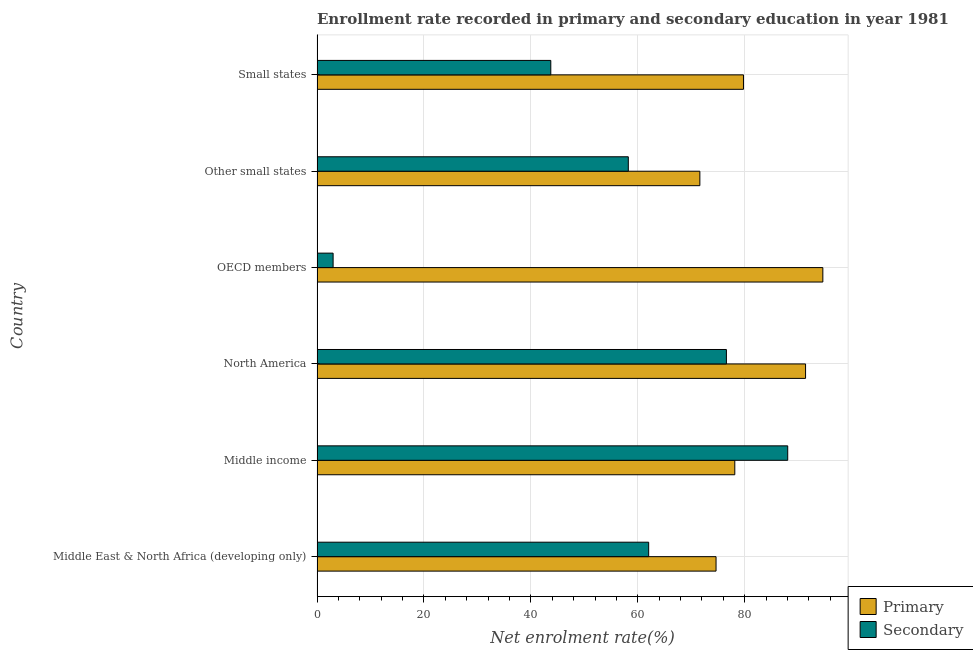How many different coloured bars are there?
Ensure brevity in your answer.  2. How many groups of bars are there?
Your answer should be compact. 6. Are the number of bars per tick equal to the number of legend labels?
Offer a very short reply. Yes. How many bars are there on the 6th tick from the top?
Give a very brief answer. 2. What is the label of the 1st group of bars from the top?
Keep it short and to the point. Small states. What is the enrollment rate in primary education in North America?
Your response must be concise. 91.38. Across all countries, what is the maximum enrollment rate in secondary education?
Your answer should be very brief. 88.04. Across all countries, what is the minimum enrollment rate in primary education?
Your answer should be compact. 71.61. In which country was the enrollment rate in secondary education minimum?
Keep it short and to the point. OECD members. What is the total enrollment rate in secondary education in the graph?
Your answer should be very brief. 331.59. What is the difference between the enrollment rate in secondary education in OECD members and that in Other small states?
Provide a succinct answer. -55.22. What is the difference between the enrollment rate in primary education in OECD members and the enrollment rate in secondary education in Middle East & North Africa (developing only)?
Provide a succinct answer. 32.58. What is the average enrollment rate in secondary education per country?
Your answer should be compact. 55.27. What is the difference between the enrollment rate in secondary education and enrollment rate in primary education in OECD members?
Ensure brevity in your answer.  -91.61. What is the ratio of the enrollment rate in secondary education in OECD members to that in Small states?
Keep it short and to the point. 0.07. Is the enrollment rate in primary education in Middle income less than that in North America?
Keep it short and to the point. Yes. Is the difference between the enrollment rate in secondary education in Other small states and Small states greater than the difference between the enrollment rate in primary education in Other small states and Small states?
Provide a short and direct response. Yes. What is the difference between the highest and the second highest enrollment rate in secondary education?
Offer a very short reply. 11.47. What is the difference between the highest and the lowest enrollment rate in secondary education?
Offer a terse response. 85.04. What does the 2nd bar from the top in Small states represents?
Your answer should be very brief. Primary. What does the 2nd bar from the bottom in Middle income represents?
Make the answer very short. Secondary. How many bars are there?
Provide a short and direct response. 12. How many countries are there in the graph?
Offer a terse response. 6. Are the values on the major ticks of X-axis written in scientific E-notation?
Your answer should be compact. No. Does the graph contain any zero values?
Offer a terse response. No. Does the graph contain grids?
Your response must be concise. Yes. How many legend labels are there?
Provide a succinct answer. 2. What is the title of the graph?
Your answer should be very brief. Enrollment rate recorded in primary and secondary education in year 1981. Does "Urban" appear as one of the legend labels in the graph?
Offer a very short reply. No. What is the label or title of the X-axis?
Your answer should be very brief. Net enrolment rate(%). What is the label or title of the Y-axis?
Offer a very short reply. Country. What is the Net enrolment rate(%) of Primary in Middle East & North Africa (developing only)?
Keep it short and to the point. 74.63. What is the Net enrolment rate(%) in Secondary in Middle East & North Africa (developing only)?
Offer a very short reply. 62.03. What is the Net enrolment rate(%) in Primary in Middle income?
Provide a short and direct response. 78.14. What is the Net enrolment rate(%) of Secondary in Middle income?
Offer a very short reply. 88.04. What is the Net enrolment rate(%) of Primary in North America?
Ensure brevity in your answer.  91.38. What is the Net enrolment rate(%) in Secondary in North America?
Your response must be concise. 76.57. What is the Net enrolment rate(%) of Primary in OECD members?
Offer a very short reply. 94.61. What is the Net enrolment rate(%) in Secondary in OECD members?
Your answer should be very brief. 3. What is the Net enrolment rate(%) of Primary in Other small states?
Make the answer very short. 71.61. What is the Net enrolment rate(%) in Secondary in Other small states?
Ensure brevity in your answer.  58.22. What is the Net enrolment rate(%) in Primary in Small states?
Ensure brevity in your answer.  79.76. What is the Net enrolment rate(%) in Secondary in Small states?
Make the answer very short. 43.72. Across all countries, what is the maximum Net enrolment rate(%) in Primary?
Your answer should be very brief. 94.61. Across all countries, what is the maximum Net enrolment rate(%) in Secondary?
Provide a succinct answer. 88.04. Across all countries, what is the minimum Net enrolment rate(%) of Primary?
Keep it short and to the point. 71.61. Across all countries, what is the minimum Net enrolment rate(%) in Secondary?
Give a very brief answer. 3. What is the total Net enrolment rate(%) of Primary in the graph?
Your answer should be compact. 490.13. What is the total Net enrolment rate(%) of Secondary in the graph?
Offer a terse response. 331.59. What is the difference between the Net enrolment rate(%) in Primary in Middle East & North Africa (developing only) and that in Middle income?
Your response must be concise. -3.51. What is the difference between the Net enrolment rate(%) of Secondary in Middle East & North Africa (developing only) and that in Middle income?
Offer a very short reply. -26.01. What is the difference between the Net enrolment rate(%) in Primary in Middle East & North Africa (developing only) and that in North America?
Your answer should be very brief. -16.75. What is the difference between the Net enrolment rate(%) in Secondary in Middle East & North Africa (developing only) and that in North America?
Ensure brevity in your answer.  -14.54. What is the difference between the Net enrolment rate(%) of Primary in Middle East & North Africa (developing only) and that in OECD members?
Offer a very short reply. -19.98. What is the difference between the Net enrolment rate(%) in Secondary in Middle East & North Africa (developing only) and that in OECD members?
Your response must be concise. 59.03. What is the difference between the Net enrolment rate(%) in Primary in Middle East & North Africa (developing only) and that in Other small states?
Ensure brevity in your answer.  3.03. What is the difference between the Net enrolment rate(%) of Secondary in Middle East & North Africa (developing only) and that in Other small states?
Your answer should be compact. 3.81. What is the difference between the Net enrolment rate(%) of Primary in Middle East & North Africa (developing only) and that in Small states?
Make the answer very short. -5.13. What is the difference between the Net enrolment rate(%) of Secondary in Middle East & North Africa (developing only) and that in Small states?
Your answer should be very brief. 18.31. What is the difference between the Net enrolment rate(%) in Primary in Middle income and that in North America?
Offer a very short reply. -13.24. What is the difference between the Net enrolment rate(%) of Secondary in Middle income and that in North America?
Your answer should be compact. 11.47. What is the difference between the Net enrolment rate(%) in Primary in Middle income and that in OECD members?
Provide a short and direct response. -16.47. What is the difference between the Net enrolment rate(%) of Secondary in Middle income and that in OECD members?
Provide a short and direct response. 85.04. What is the difference between the Net enrolment rate(%) in Primary in Middle income and that in Other small states?
Your answer should be compact. 6.53. What is the difference between the Net enrolment rate(%) in Secondary in Middle income and that in Other small states?
Give a very brief answer. 29.82. What is the difference between the Net enrolment rate(%) of Primary in Middle income and that in Small states?
Provide a short and direct response. -1.62. What is the difference between the Net enrolment rate(%) in Secondary in Middle income and that in Small states?
Give a very brief answer. 44.32. What is the difference between the Net enrolment rate(%) in Primary in North America and that in OECD members?
Provide a short and direct response. -3.23. What is the difference between the Net enrolment rate(%) of Secondary in North America and that in OECD members?
Your answer should be very brief. 73.57. What is the difference between the Net enrolment rate(%) of Primary in North America and that in Other small states?
Offer a very short reply. 19.77. What is the difference between the Net enrolment rate(%) of Secondary in North America and that in Other small states?
Provide a succinct answer. 18.35. What is the difference between the Net enrolment rate(%) in Primary in North America and that in Small states?
Ensure brevity in your answer.  11.62. What is the difference between the Net enrolment rate(%) in Secondary in North America and that in Small states?
Your answer should be very brief. 32.85. What is the difference between the Net enrolment rate(%) of Primary in OECD members and that in Other small states?
Offer a very short reply. 23. What is the difference between the Net enrolment rate(%) in Secondary in OECD members and that in Other small states?
Make the answer very short. -55.22. What is the difference between the Net enrolment rate(%) of Primary in OECD members and that in Small states?
Give a very brief answer. 14.85. What is the difference between the Net enrolment rate(%) of Secondary in OECD members and that in Small states?
Make the answer very short. -40.72. What is the difference between the Net enrolment rate(%) of Primary in Other small states and that in Small states?
Provide a short and direct response. -8.16. What is the difference between the Net enrolment rate(%) of Secondary in Other small states and that in Small states?
Your response must be concise. 14.5. What is the difference between the Net enrolment rate(%) in Primary in Middle East & North Africa (developing only) and the Net enrolment rate(%) in Secondary in Middle income?
Provide a succinct answer. -13.41. What is the difference between the Net enrolment rate(%) of Primary in Middle East & North Africa (developing only) and the Net enrolment rate(%) of Secondary in North America?
Your answer should be very brief. -1.94. What is the difference between the Net enrolment rate(%) in Primary in Middle East & North Africa (developing only) and the Net enrolment rate(%) in Secondary in OECD members?
Ensure brevity in your answer.  71.63. What is the difference between the Net enrolment rate(%) of Primary in Middle East & North Africa (developing only) and the Net enrolment rate(%) of Secondary in Other small states?
Ensure brevity in your answer.  16.41. What is the difference between the Net enrolment rate(%) of Primary in Middle East & North Africa (developing only) and the Net enrolment rate(%) of Secondary in Small states?
Offer a terse response. 30.91. What is the difference between the Net enrolment rate(%) of Primary in Middle income and the Net enrolment rate(%) of Secondary in North America?
Keep it short and to the point. 1.57. What is the difference between the Net enrolment rate(%) in Primary in Middle income and the Net enrolment rate(%) in Secondary in OECD members?
Provide a succinct answer. 75.14. What is the difference between the Net enrolment rate(%) in Primary in Middle income and the Net enrolment rate(%) in Secondary in Other small states?
Your answer should be compact. 19.92. What is the difference between the Net enrolment rate(%) in Primary in Middle income and the Net enrolment rate(%) in Secondary in Small states?
Your answer should be very brief. 34.42. What is the difference between the Net enrolment rate(%) in Primary in North America and the Net enrolment rate(%) in Secondary in OECD members?
Your answer should be compact. 88.37. What is the difference between the Net enrolment rate(%) in Primary in North America and the Net enrolment rate(%) in Secondary in Other small states?
Keep it short and to the point. 33.16. What is the difference between the Net enrolment rate(%) in Primary in North America and the Net enrolment rate(%) in Secondary in Small states?
Provide a succinct answer. 47.66. What is the difference between the Net enrolment rate(%) in Primary in OECD members and the Net enrolment rate(%) in Secondary in Other small states?
Give a very brief answer. 36.39. What is the difference between the Net enrolment rate(%) of Primary in OECD members and the Net enrolment rate(%) of Secondary in Small states?
Your answer should be very brief. 50.89. What is the difference between the Net enrolment rate(%) of Primary in Other small states and the Net enrolment rate(%) of Secondary in Small states?
Provide a succinct answer. 27.89. What is the average Net enrolment rate(%) in Primary per country?
Offer a very short reply. 81.69. What is the average Net enrolment rate(%) of Secondary per country?
Provide a short and direct response. 55.27. What is the difference between the Net enrolment rate(%) of Primary and Net enrolment rate(%) of Secondary in Middle East & North Africa (developing only)?
Your response must be concise. 12.6. What is the difference between the Net enrolment rate(%) of Primary and Net enrolment rate(%) of Secondary in Middle income?
Make the answer very short. -9.9. What is the difference between the Net enrolment rate(%) of Primary and Net enrolment rate(%) of Secondary in North America?
Ensure brevity in your answer.  14.81. What is the difference between the Net enrolment rate(%) in Primary and Net enrolment rate(%) in Secondary in OECD members?
Give a very brief answer. 91.61. What is the difference between the Net enrolment rate(%) in Primary and Net enrolment rate(%) in Secondary in Other small states?
Your answer should be compact. 13.39. What is the difference between the Net enrolment rate(%) in Primary and Net enrolment rate(%) in Secondary in Small states?
Offer a terse response. 36.04. What is the ratio of the Net enrolment rate(%) in Primary in Middle East & North Africa (developing only) to that in Middle income?
Make the answer very short. 0.96. What is the ratio of the Net enrolment rate(%) of Secondary in Middle East & North Africa (developing only) to that in Middle income?
Your response must be concise. 0.7. What is the ratio of the Net enrolment rate(%) in Primary in Middle East & North Africa (developing only) to that in North America?
Your answer should be compact. 0.82. What is the ratio of the Net enrolment rate(%) in Secondary in Middle East & North Africa (developing only) to that in North America?
Make the answer very short. 0.81. What is the ratio of the Net enrolment rate(%) of Primary in Middle East & North Africa (developing only) to that in OECD members?
Give a very brief answer. 0.79. What is the ratio of the Net enrolment rate(%) in Secondary in Middle East & North Africa (developing only) to that in OECD members?
Your answer should be compact. 20.65. What is the ratio of the Net enrolment rate(%) of Primary in Middle East & North Africa (developing only) to that in Other small states?
Ensure brevity in your answer.  1.04. What is the ratio of the Net enrolment rate(%) of Secondary in Middle East & North Africa (developing only) to that in Other small states?
Your response must be concise. 1.07. What is the ratio of the Net enrolment rate(%) in Primary in Middle East & North Africa (developing only) to that in Small states?
Provide a succinct answer. 0.94. What is the ratio of the Net enrolment rate(%) of Secondary in Middle East & North Africa (developing only) to that in Small states?
Provide a short and direct response. 1.42. What is the ratio of the Net enrolment rate(%) of Primary in Middle income to that in North America?
Your answer should be compact. 0.86. What is the ratio of the Net enrolment rate(%) in Secondary in Middle income to that in North America?
Provide a succinct answer. 1.15. What is the ratio of the Net enrolment rate(%) of Primary in Middle income to that in OECD members?
Provide a short and direct response. 0.83. What is the ratio of the Net enrolment rate(%) in Secondary in Middle income to that in OECD members?
Your answer should be very brief. 29.31. What is the ratio of the Net enrolment rate(%) of Primary in Middle income to that in Other small states?
Provide a short and direct response. 1.09. What is the ratio of the Net enrolment rate(%) in Secondary in Middle income to that in Other small states?
Make the answer very short. 1.51. What is the ratio of the Net enrolment rate(%) in Primary in Middle income to that in Small states?
Your response must be concise. 0.98. What is the ratio of the Net enrolment rate(%) of Secondary in Middle income to that in Small states?
Your answer should be compact. 2.01. What is the ratio of the Net enrolment rate(%) in Primary in North America to that in OECD members?
Provide a short and direct response. 0.97. What is the ratio of the Net enrolment rate(%) in Secondary in North America to that in OECD members?
Your answer should be compact. 25.49. What is the ratio of the Net enrolment rate(%) of Primary in North America to that in Other small states?
Give a very brief answer. 1.28. What is the ratio of the Net enrolment rate(%) of Secondary in North America to that in Other small states?
Provide a short and direct response. 1.32. What is the ratio of the Net enrolment rate(%) in Primary in North America to that in Small states?
Provide a succinct answer. 1.15. What is the ratio of the Net enrolment rate(%) in Secondary in North America to that in Small states?
Offer a terse response. 1.75. What is the ratio of the Net enrolment rate(%) of Primary in OECD members to that in Other small states?
Provide a short and direct response. 1.32. What is the ratio of the Net enrolment rate(%) of Secondary in OECD members to that in Other small states?
Make the answer very short. 0.05. What is the ratio of the Net enrolment rate(%) of Primary in OECD members to that in Small states?
Make the answer very short. 1.19. What is the ratio of the Net enrolment rate(%) in Secondary in OECD members to that in Small states?
Give a very brief answer. 0.07. What is the ratio of the Net enrolment rate(%) of Primary in Other small states to that in Small states?
Provide a short and direct response. 0.9. What is the ratio of the Net enrolment rate(%) of Secondary in Other small states to that in Small states?
Keep it short and to the point. 1.33. What is the difference between the highest and the second highest Net enrolment rate(%) of Primary?
Your answer should be compact. 3.23. What is the difference between the highest and the second highest Net enrolment rate(%) in Secondary?
Your answer should be very brief. 11.47. What is the difference between the highest and the lowest Net enrolment rate(%) of Primary?
Provide a succinct answer. 23. What is the difference between the highest and the lowest Net enrolment rate(%) of Secondary?
Your answer should be very brief. 85.04. 